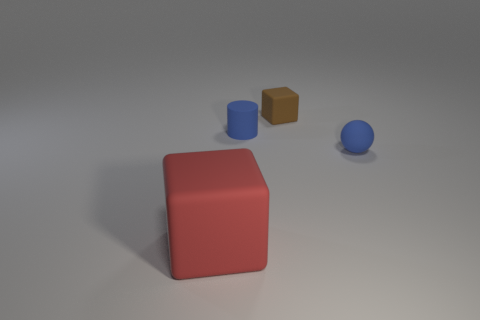Add 3 big yellow cylinders. How many objects exist? 7 Subtract all cylinders. How many objects are left? 3 Add 3 tiny cubes. How many tiny cubes exist? 4 Subtract 0 cyan cylinders. How many objects are left? 4 Subtract all tiny brown rubber objects. Subtract all small things. How many objects are left? 0 Add 2 tiny blue rubber cylinders. How many tiny blue rubber cylinders are left? 3 